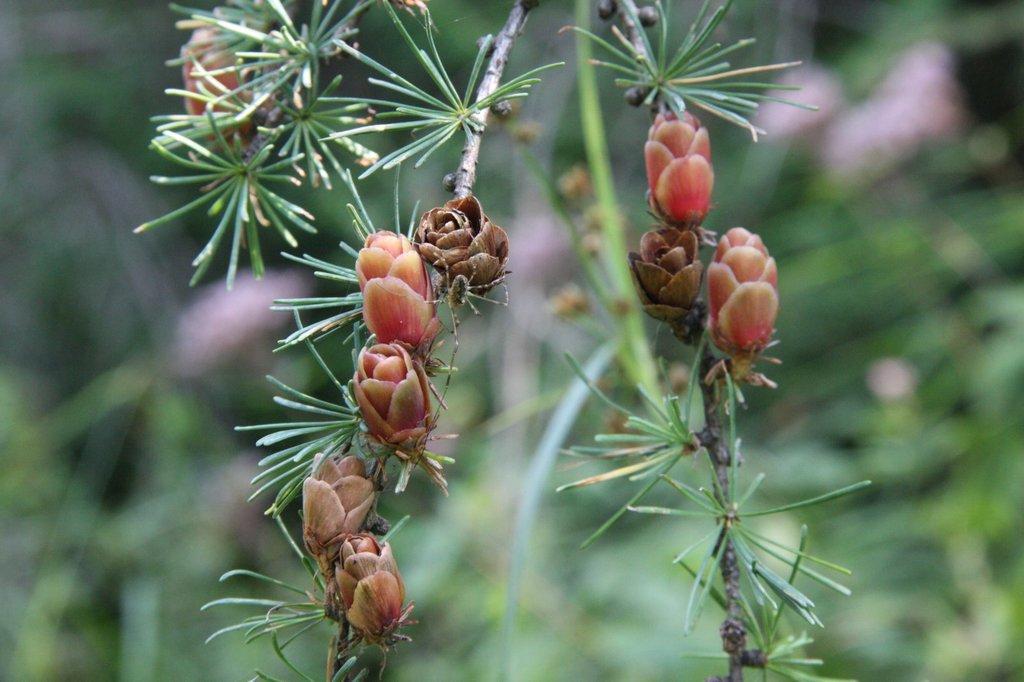Could you give a brief overview of what you see in this image? This picture seems to be clicked outside. In the foreground we can see the stems, buds and some other objects. The background of the image is blurry. 